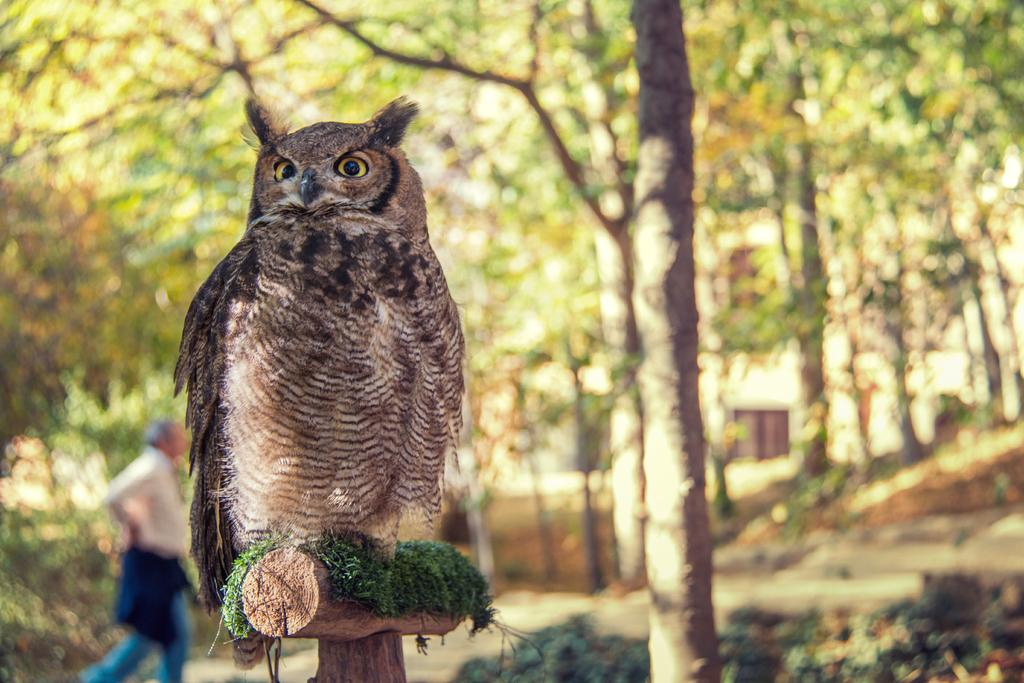What type of animal is in the image? There is an owl in the image. What is the owl standing on? The owl is standing on a wooden stand. What can be seen in the background of the image? There are trees visible in the image. Is there a person present in the image? Yes, there is a person in the image. What type of alley is visible in the image? There is no alley present in the image. 